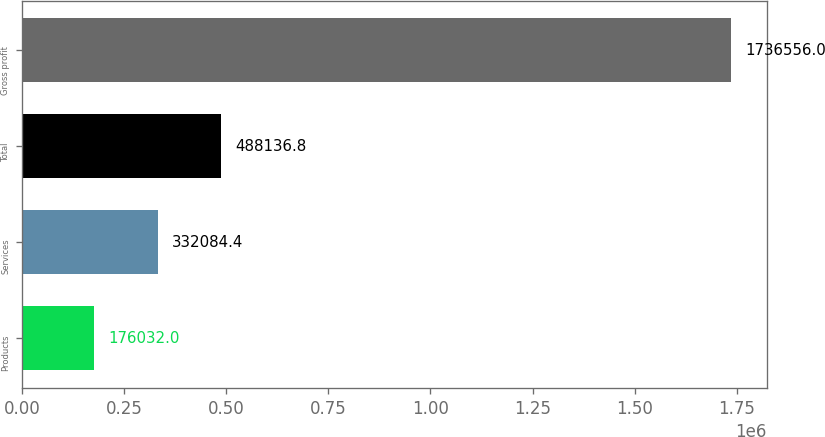Convert chart. <chart><loc_0><loc_0><loc_500><loc_500><bar_chart><fcel>Products<fcel>Services<fcel>Total<fcel>Gross profit<nl><fcel>176032<fcel>332084<fcel>488137<fcel>1.73656e+06<nl></chart> 